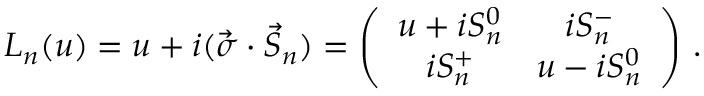<formula> <loc_0><loc_0><loc_500><loc_500>L _ { n } ( u ) = u + i ( \vec { \sigma } \cdot \vec { S } _ { n } ) = \left ( \begin{array} { c c } { { u + i S _ { n } ^ { 0 } } } & { { i S _ { n } ^ { - } } } \\ { { i S _ { n } ^ { + } } } & { { u - i S _ { n } ^ { 0 } } } \end{array} \right ) \, .</formula> 